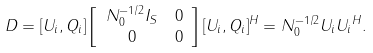Convert formula to latex. <formula><loc_0><loc_0><loc_500><loc_500>D & = [ U _ { i } , Q _ { i } ] \left [ \begin{array} { c c } N _ { 0 } ^ { - 1 / 2 } I _ { S } & 0 \\ 0 & 0 \end{array} \right ] [ U _ { i } , Q _ { i } ] ^ { H } = N _ { 0 } ^ { - 1 / 2 } U _ { i } { U _ { i } } ^ { H } .</formula> 